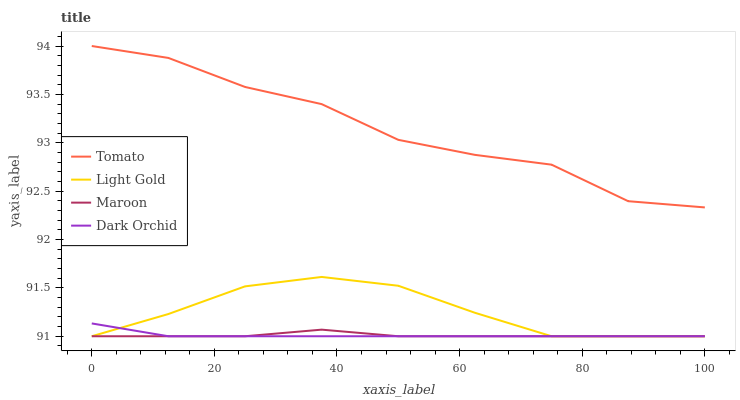Does Light Gold have the minimum area under the curve?
Answer yes or no. No. Does Light Gold have the maximum area under the curve?
Answer yes or no. No. Is Light Gold the smoothest?
Answer yes or no. No. Is Light Gold the roughest?
Answer yes or no. No. Does Light Gold have the highest value?
Answer yes or no. No. Is Light Gold less than Tomato?
Answer yes or no. Yes. Is Tomato greater than Dark Orchid?
Answer yes or no. Yes. Does Light Gold intersect Tomato?
Answer yes or no. No. 